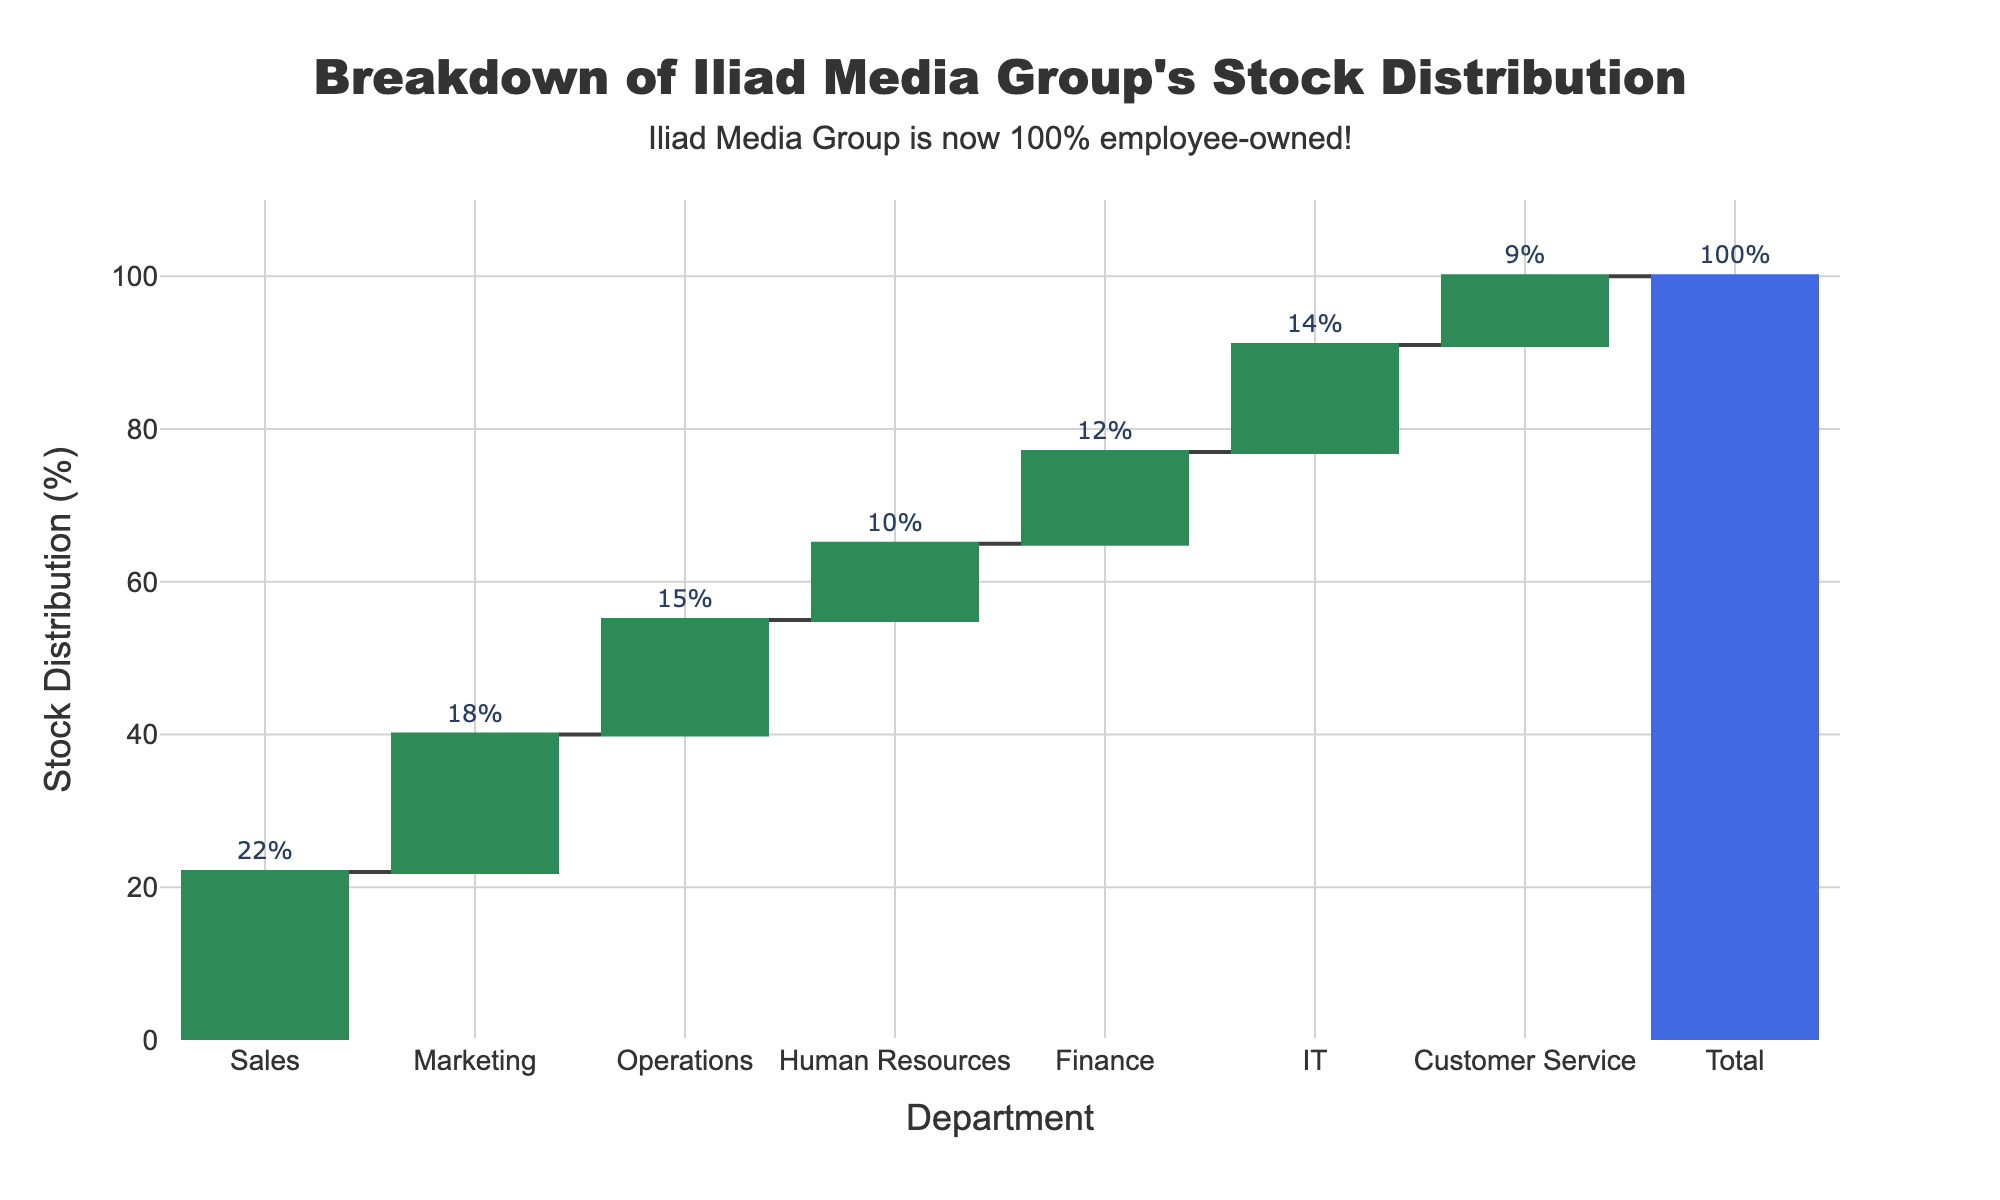What's the title of the chart? The title is displayed at the top center of the chart. It reads, "Breakdown of Iliad Media Group's Stock Distribution".
Answer: Breakdown of Iliad Media Group's Stock Distribution How many departments are shown in the chart? Count the number of bars representing departments on the x-axis. There are 7 bars, each representing a different department.
Answer: 7 Which department received the highest percentage of stock distribution? Look at the heights of the bars in the chart and identify the one that extends the highest. The bar for Sales is the tallest, indicating the highest percentage.
Answer: Sales What is the stock distribution percentage for the IT department? Locate the bar corresponding to the IT department and read the percentage value displayed on the bar. The IT department has a 14% stock distribution.
Answer: 14% What is the sum of the stock distribution percentages for Sales and Marketing? Add the percentages of the Sales and Marketing departments. Sales has 22% and Marketing has 18%, so 22 + 18 = 40%.
Answer: 40% Which department has the smallest stock distribution percentage, and what is it? Find the shortest bar and read its value. The Customer Service department has the smallest percentage at 9%.
Answer: Customer Service, 9% What's the difference in stock distribution percentages between the Operations and Finance departments? Subtract the percentage of Finance (12%) from Operations (15%). The difference is 15 - 12 = 3%.
Answer: 3% If you combine the percentages of Human Resources and Finance, what fraction of the total stock distribution does it represent? Add the percentages of Human Resources (10%) and Finance (12%) to get 22%. The total is 100%, so the fraction is 22/100 or 11/50.
Answer: 11/50 By how much does the combined stock distribution of IT and Customer Service exceed that of Marketing? Add IT (14%) and Customer Service (9%), which equals 23%. Subtract Marketing's 18% from 23% to get 5%.
Answer: 5% Why is the bar for the 'Total' labeled differently from the other bars? The 'Total' bar is colored differently and sums up the overall stock distribution, ensuring that all percentages add up to 100%. This is typical in waterfall charts to verify the total.
Answer: To verify 100% total 